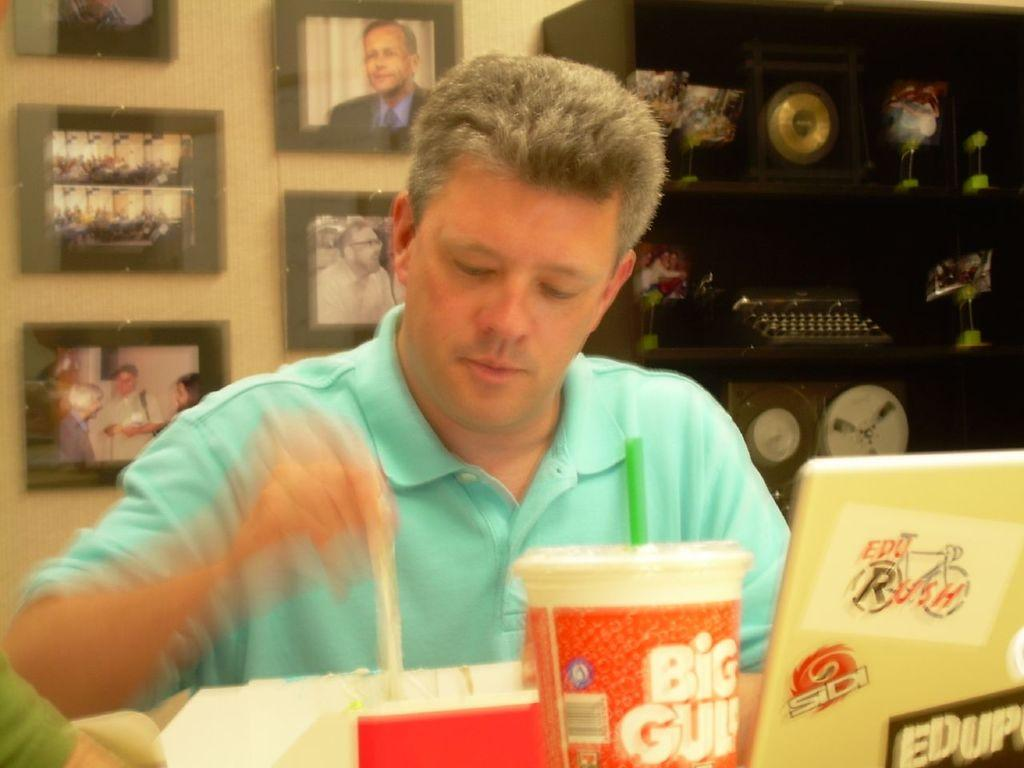<image>
Give a short and clear explanation of the subsequent image. A man is sitting at a table with a Big Gulp cup in front of him. 